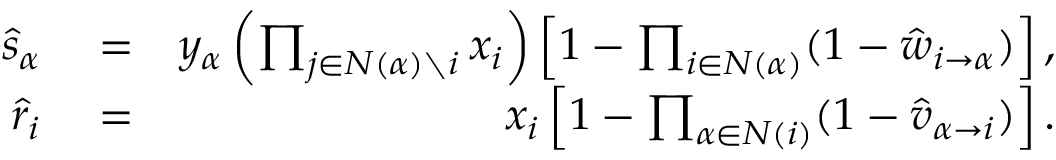Convert formula to latex. <formula><loc_0><loc_0><loc_500><loc_500>\begin{array} { r l r } { \, \hat { s } _ { \alpha } } & = } & { y _ { \alpha } \left ( \prod _ { j \in N ( \alpha ) \ i } x _ { i } \right ) \left [ 1 - \prod _ { i \in N ( \alpha ) } ( 1 - \hat { w } _ { i \rightarrow \alpha } ) \right ] , } \\ { \, \hat { r } _ { i } } & = } & { x _ { i } \left [ 1 - \prod _ { \alpha \in N ( i ) } ( 1 - \hat { v } _ { \alpha \rightarrow i } ) \right ] . } \end{array}</formula> 